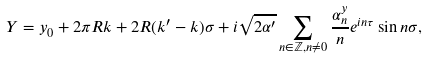<formula> <loc_0><loc_0><loc_500><loc_500>Y = y _ { 0 } + 2 \pi R k + 2 R ( k ^ { \prime } - k ) \sigma + i \sqrt { 2 \alpha ^ { \prime } } \sum _ { n \in { \mathbb { Z } } , n \neq 0 } \frac { \alpha ^ { y } _ { n } } { n } e ^ { i n \tau } \sin n \sigma ,</formula> 